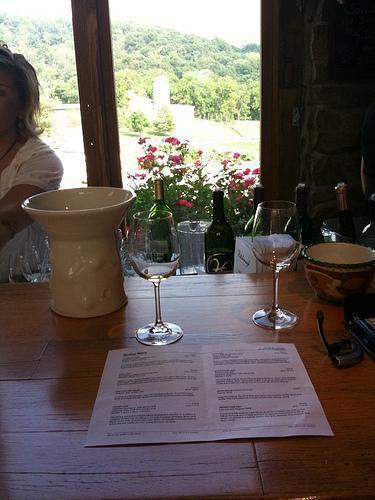How many glasses are on the table?
Give a very brief answer. 2. How many people are partially visible?
Give a very brief answer. 1. How many wine bottles?
Give a very brief answer. 5. How many wine glasses are in the picture?
Give a very brief answer. 2. How many elephants are in the picture?
Give a very brief answer. 0. 